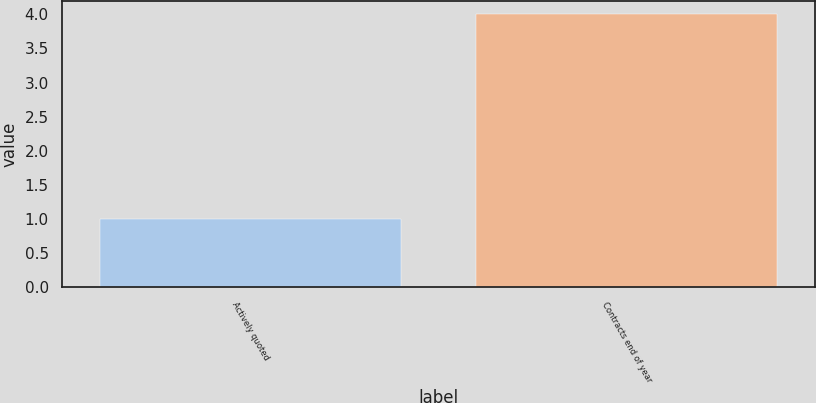Convert chart to OTSL. <chart><loc_0><loc_0><loc_500><loc_500><bar_chart><fcel>Actively quoted<fcel>Contracts end of year<nl><fcel>1<fcel>4<nl></chart> 